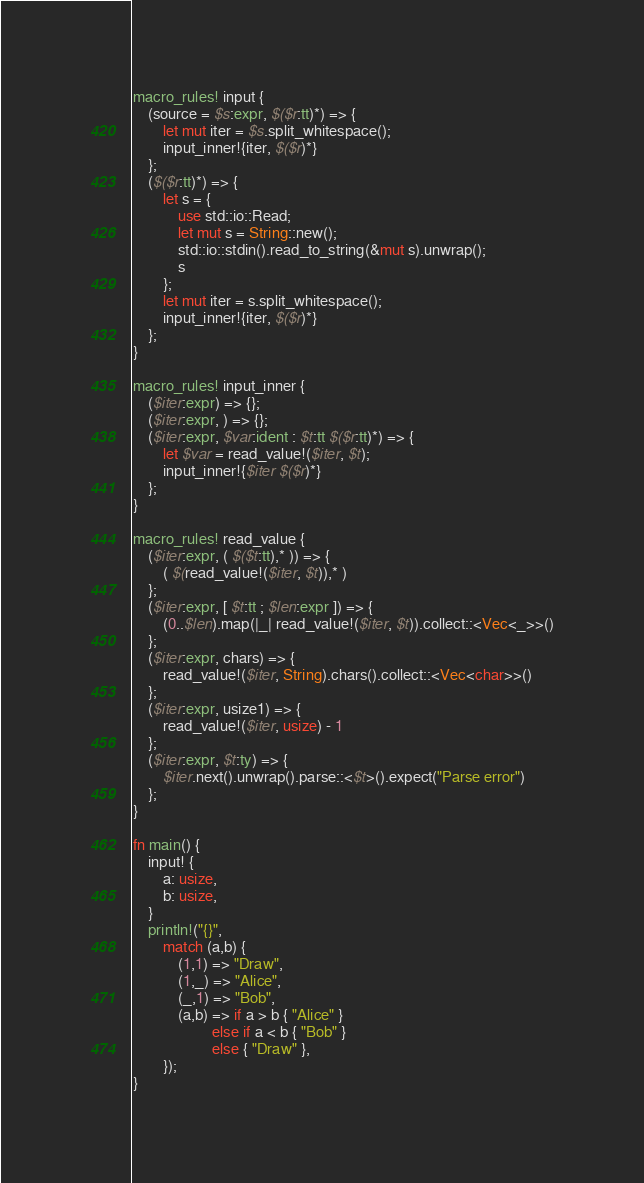<code> <loc_0><loc_0><loc_500><loc_500><_Rust_>macro_rules! input {
    (source = $s:expr, $($r:tt)*) => {
        let mut iter = $s.split_whitespace();
        input_inner!{iter, $($r)*}
    };
    ($($r:tt)*) => {
        let s = {
            use std::io::Read;
            let mut s = String::new();
            std::io::stdin().read_to_string(&mut s).unwrap();
            s
        };
        let mut iter = s.split_whitespace();
        input_inner!{iter, $($r)*}
    };
}

macro_rules! input_inner {
    ($iter:expr) => {};
    ($iter:expr, ) => {};
    ($iter:expr, $var:ident : $t:tt $($r:tt)*) => {
        let $var = read_value!($iter, $t);
        input_inner!{$iter $($r)*}
    };
}

macro_rules! read_value {
    ($iter:expr, ( $($t:tt),* )) => {
        ( $(read_value!($iter, $t)),* )
    };
    ($iter:expr, [ $t:tt ; $len:expr ]) => {
        (0..$len).map(|_| read_value!($iter, $t)).collect::<Vec<_>>()
    };
    ($iter:expr, chars) => {
        read_value!($iter, String).chars().collect::<Vec<char>>()
    };
    ($iter:expr, usize1) => {
        read_value!($iter, usize) - 1
    };
    ($iter:expr, $t:ty) => {
        $iter.next().unwrap().parse::<$t>().expect("Parse error")
    };
}

fn main() {
    input! {
        a: usize,
        b: usize,
    }
    println!("{}",
        match (a,b) {
            (1,1) => "Draw",
            (1,_) => "Alice",
            (_,1) => "Bob",
            (a,b) => if a > b { "Alice" }
                     else if a < b { "Bob" }
                     else { "Draw" },
        });
}
</code> 